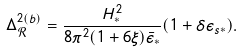<formula> <loc_0><loc_0><loc_500><loc_500>\Delta ^ { 2 ( b ) } _ { \mathcal { R } } & = \frac { H _ { * } ^ { 2 } } { 8 \pi ^ { 2 } ( 1 + 6 \xi ) \bar { \epsilon } _ { * } } ( 1 + \delta \epsilon _ { s * } ) .</formula> 